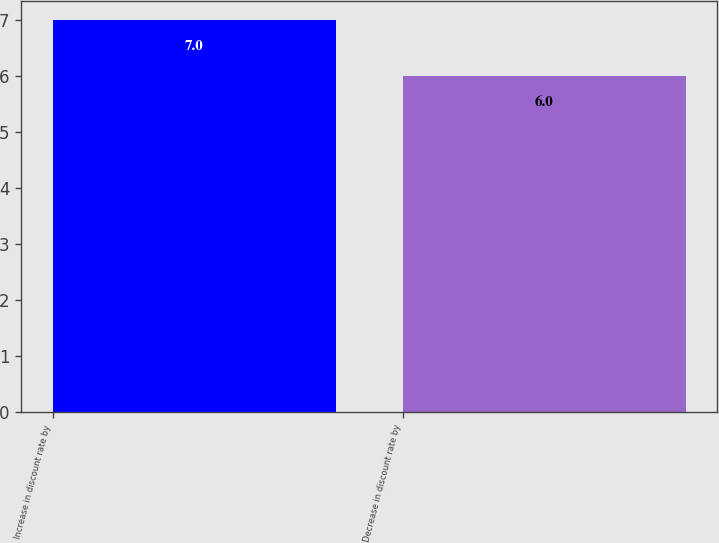Convert chart. <chart><loc_0><loc_0><loc_500><loc_500><bar_chart><fcel>Increase in discount rate by<fcel>Decrease in discount rate by<nl><fcel>7<fcel>6<nl></chart> 